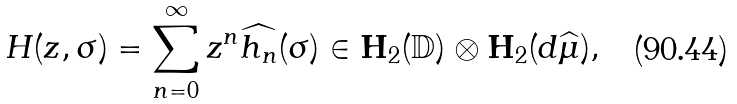Convert formula to latex. <formula><loc_0><loc_0><loc_500><loc_500>H ( z , \sigma ) = \sum _ { n = 0 } ^ { \infty } z ^ { n } \widehat { h _ { n } } ( \sigma ) \in { \mathbf H } _ { 2 } ( { \mathbb { D } } ) \otimes { \mathbf H } _ { 2 } ( d \widehat { \mu } ) ,</formula> 